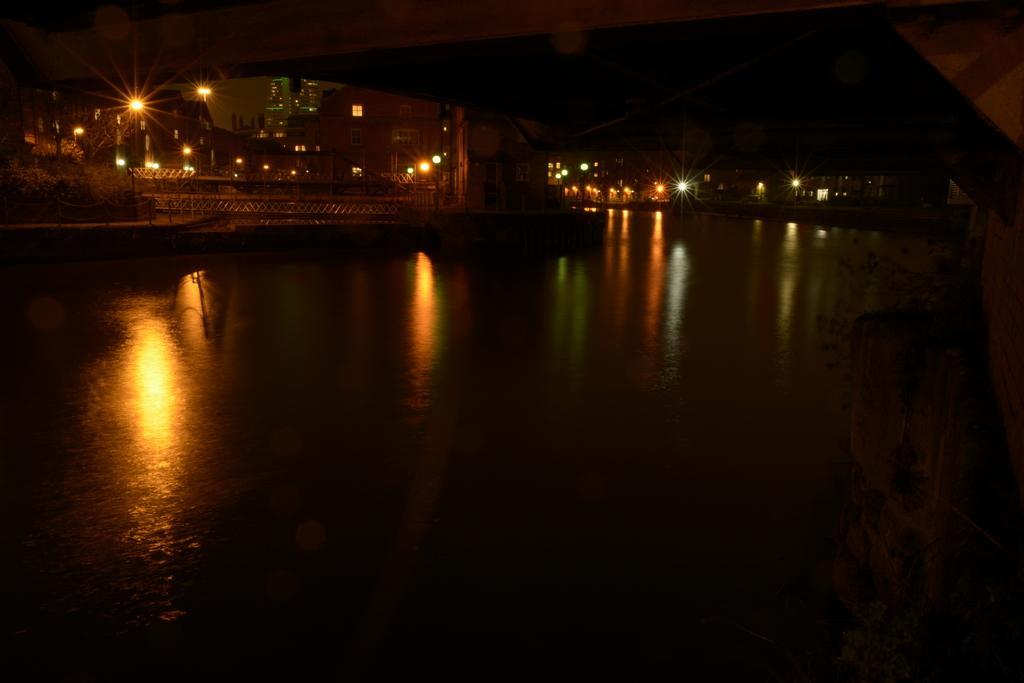How would you summarize this image in a sentence or two? The image is dark. At the bottom we can see water. In the background there are buildings, light poles, windows and other objects. On the right side we can see the plants and wall. 